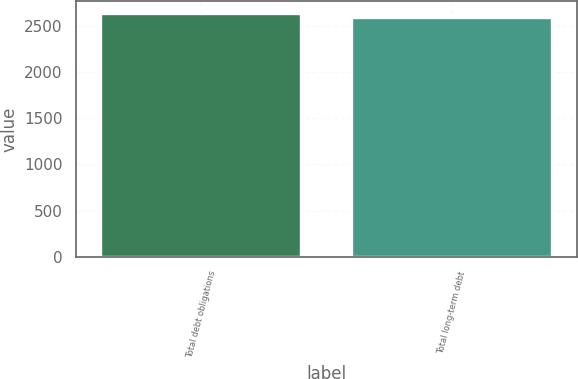Convert chart to OTSL. <chart><loc_0><loc_0><loc_500><loc_500><bar_chart><fcel>Total debt obligations<fcel>Total long-term debt<nl><fcel>2634<fcel>2589<nl></chart> 